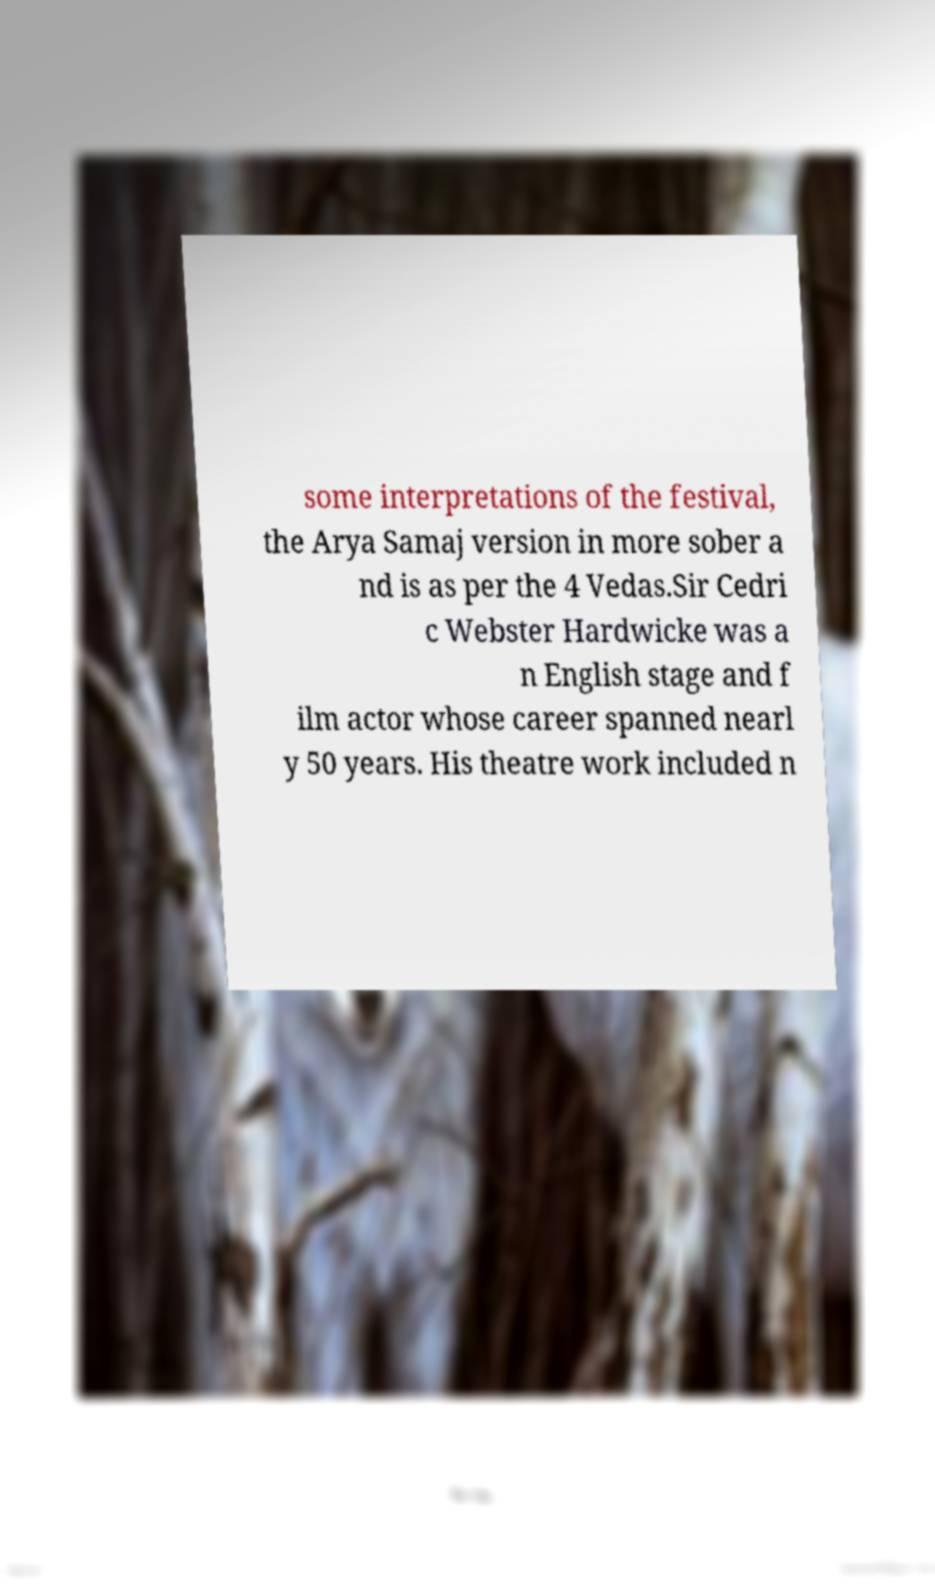Please read and relay the text visible in this image. What does it say? some interpretations of the festival, the Arya Samaj version in more sober a nd is as per the 4 Vedas.Sir Cedri c Webster Hardwicke was a n English stage and f ilm actor whose career spanned nearl y 50 years. His theatre work included n 